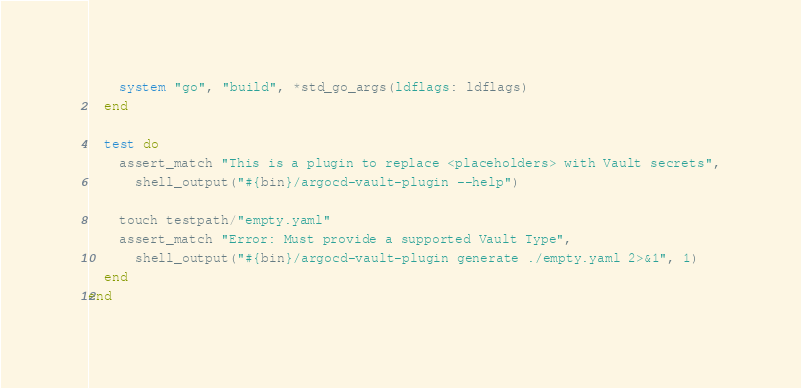Convert code to text. <code><loc_0><loc_0><loc_500><loc_500><_Ruby_>    system "go", "build", *std_go_args(ldflags: ldflags)
  end

  test do
    assert_match "This is a plugin to replace <placeholders> with Vault secrets",
      shell_output("#{bin}/argocd-vault-plugin --help")

    touch testpath/"empty.yaml"
    assert_match "Error: Must provide a supported Vault Type",
      shell_output("#{bin}/argocd-vault-plugin generate ./empty.yaml 2>&1", 1)
  end
end
</code> 